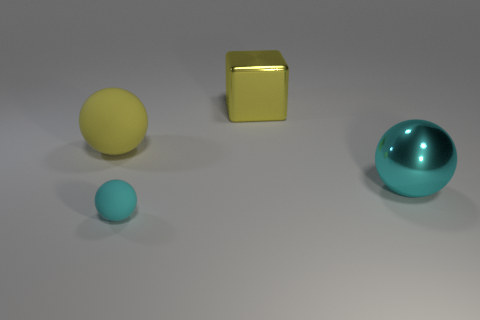What is the color of the other shiny object that is the same shape as the tiny thing?
Offer a terse response. Cyan. Is the size of the object that is on the right side of the shiny cube the same as the block?
Your answer should be compact. Yes. There is a cyan sphere that is to the left of the ball right of the cyan rubber object; what size is it?
Give a very brief answer. Small. Is the big cyan object made of the same material as the yellow thing that is on the left side of the cyan matte thing?
Offer a terse response. No. Are there fewer tiny cyan balls that are in front of the yellow matte sphere than objects to the left of the big yellow metallic thing?
Offer a very short reply. Yes. The big object that is made of the same material as the yellow cube is what color?
Offer a very short reply. Cyan. There is a yellow thing on the left side of the tiny matte ball; is there a shiny sphere in front of it?
Keep it short and to the point. Yes. What is the color of the shiny thing that is the same size as the yellow shiny cube?
Give a very brief answer. Cyan. What number of things are large cyan things or small cyan matte spheres?
Provide a succinct answer. 2. There is a yellow metallic object that is right of the big yellow matte sphere that is behind the ball that is on the right side of the large yellow metal block; how big is it?
Your answer should be very brief. Large. 